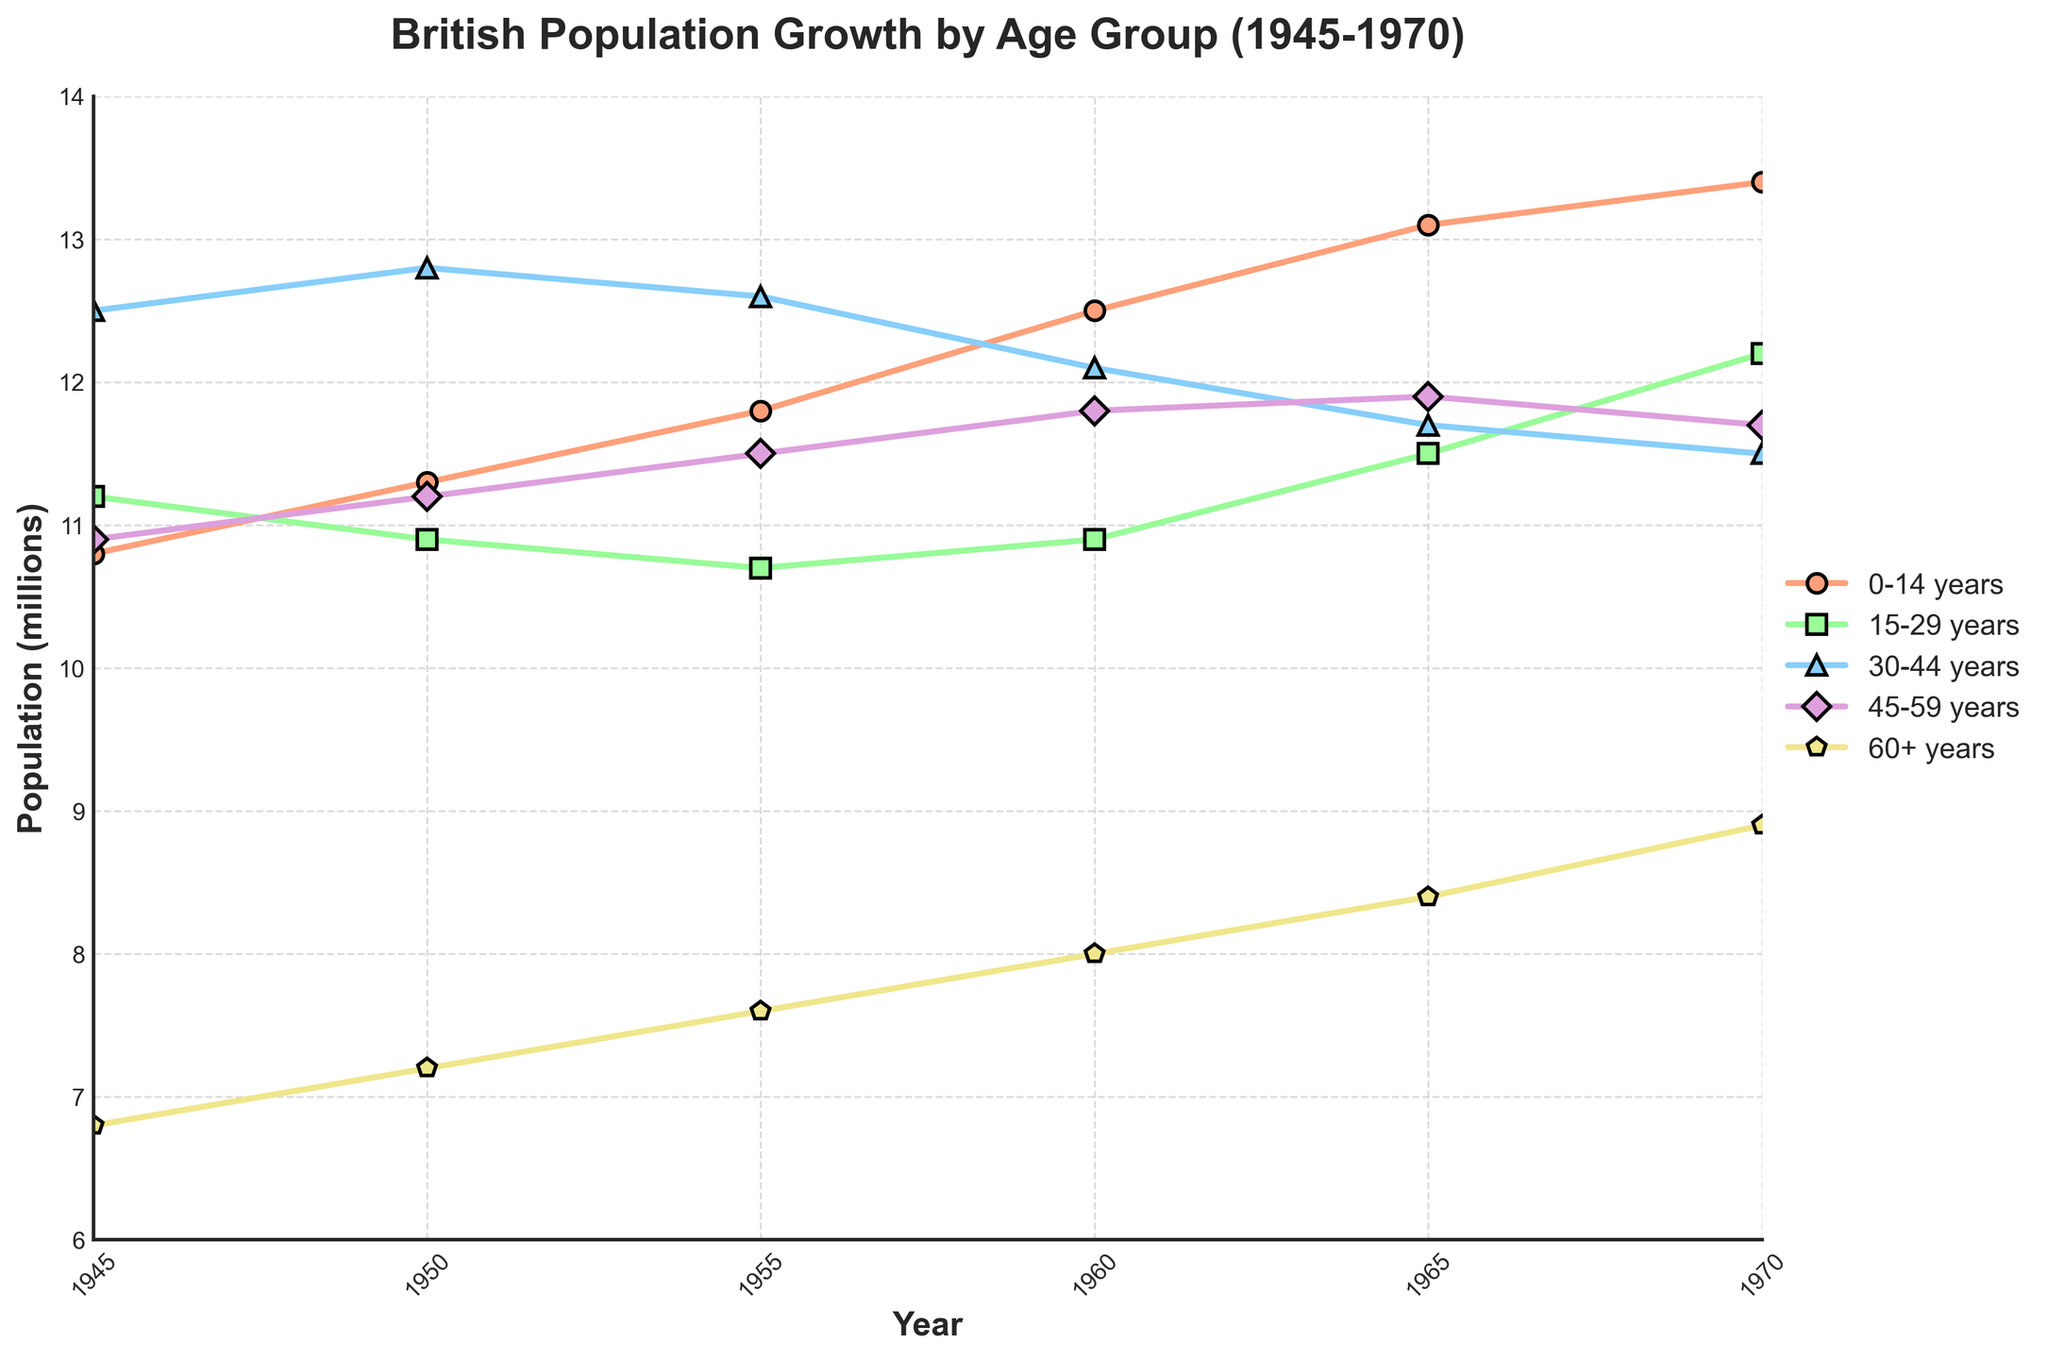Which age group experienced the largest increase in population from 1945 to 1970? To find the group with the largest increase, we need to subtract the 1945 values from the 1970 values for each age group: (13.4 - 10.8) for 0-14, (12.2 - 11.2) for 15-29, (11.5 - 12.5) for 30-44, (11.7 - 10.9) for 45-59, and (8.9 - 6.8) for 60+. The largest increase is 2.6 for the 0-14 years group.
Answer: 0-14 years Which age group had a relatively stable population throughout 1945 to 1970? We observe the line representing each age group, noting that a relatively stable trend would have minimal deviation. The 30-44 years group shows the least variation, fluctuating mildly between 12.1 and 12.8 million.
Answer: 30-44 years What was the total population of the 0-14 and 60+ age groups in 1960? Sum the population values for 0-14 (12.5) and 60+ (8.0) in 1960: 12.5 + 8.0 = 20.5 million.
Answer: 20.5 million How does the population of the 15-29 years group in 1970 compare to its population in 1950? In 1950, the 15-29 years group had a population of 10.9 million, and in 1970, it was 12.2 million. So, the population in 1970 is higher by (12.2 - 10.9) = 1.3 million.
Answer: 1.3 million increase Which age group saw a decline in population from 1945 to 1970? By comparing the 1945 and 1970 values, we see that the 30-44 years group declined from 12.5 to 11.5 million. Hence, this group experienced a population decrease of 1.0 million.
Answer: 30-44 years In 1965, which age group had the highest population, and what was its population? Looking at the values for 1965, the 0-14 years group had the highest population at 13.1 million.
Answer: 0-14 years, 13.1 million Which two age groups had an equal population at any point? In 1970, the 45-59 years and 30-44 years groups both had populations of 11.5 million.
Answer: 45-59 years and 30-44 years in 1970 By how much did the population of the 60+ years group increase from 1955 to 1970? Subtracting the 1955 value (7.6) from the 1970 value (8.9), we find the increase is 8.9 - 7.6 = 1.3 million.
Answer: 1.3 million 